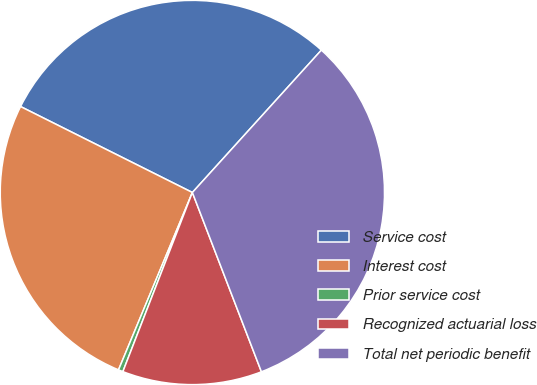Convert chart to OTSL. <chart><loc_0><loc_0><loc_500><loc_500><pie_chart><fcel>Service cost<fcel>Interest cost<fcel>Prior service cost<fcel>Recognized actuarial loss<fcel>Total net periodic benefit<nl><fcel>29.33%<fcel>26.1%<fcel>0.39%<fcel>11.74%<fcel>32.43%<nl></chart> 